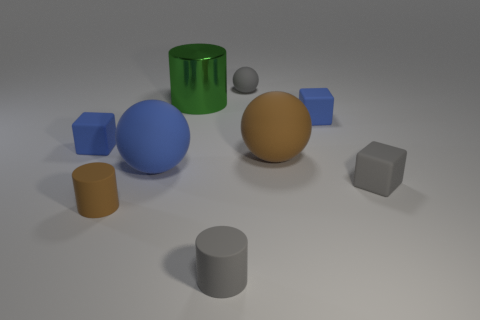Add 1 small cyan matte things. How many objects exist? 10 Subtract all green metal cylinders. How many cylinders are left? 2 Subtract all yellow balls. How many blue cubes are left? 2 Subtract all gray cylinders. How many cylinders are left? 2 Subtract all cylinders. How many objects are left? 6 Add 7 large objects. How many large objects are left? 10 Add 5 small blue rubber objects. How many small blue rubber objects exist? 7 Subtract 0 blue cylinders. How many objects are left? 9 Subtract 2 balls. How many balls are left? 1 Subtract all blue blocks. Subtract all green cylinders. How many blocks are left? 1 